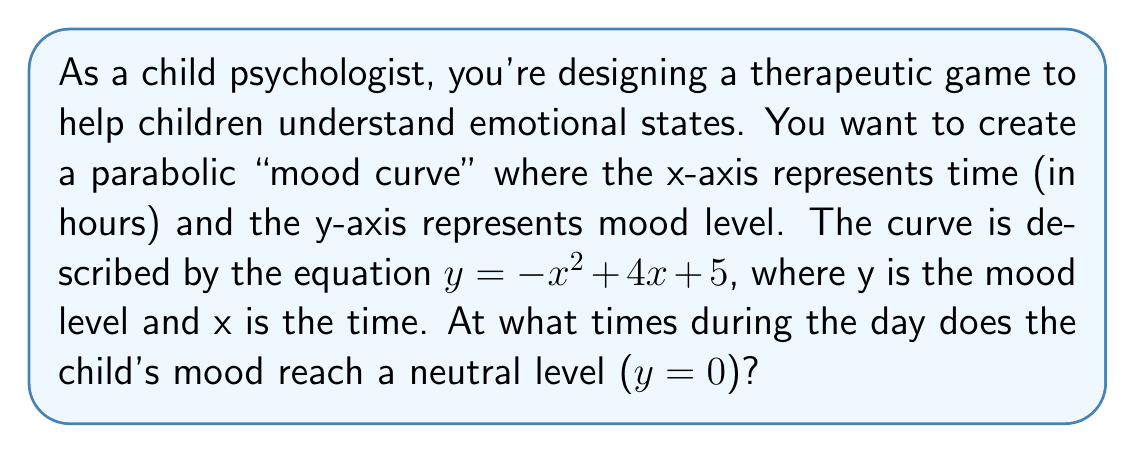Can you solve this math problem? To solve this problem, we need to find the roots of the quadratic equation:

$-x^2 + 4x + 5 = 0$

We can solve this using both factoring and the quadratic formula.

1. Factoring method:
   Unfortunately, this quadratic equation doesn't factor easily, so we'll move on to the quadratic formula.

2. Quadratic formula method:
   The quadratic formula is: $x = \frac{-b \pm \sqrt{b^2 - 4ac}}{2a}$

   Where $a = -1$, $b = 4$, and $c = 5$

   Substituting these values:

   $x = \frac{-4 \pm \sqrt{4^2 - 4(-1)(5)}}{2(-1)}$

   $x = \frac{-4 \pm \sqrt{16 + 20}}{-2}$

   $x = \frac{-4 \pm \sqrt{36}}{-2}$

   $x = \frac{-4 \pm 6}{-2}$

   This gives us two solutions:

   $x_1 = \frac{-4 + 6}{-2} = \frac{2}{-2} = -1$

   $x_2 = \frac{-4 - 6}{-2} = \frac{-10}{-2} = 5$

Therefore, the child's mood reaches a neutral level (y = 0) at -1 hour and 5 hours. Since time can't be negative in this context, we interpret -1 as 11 PM the previous day, and 5 as 5 AM.
Answer: The child's mood reaches a neutral level at 11 PM the previous day and 5 AM. 